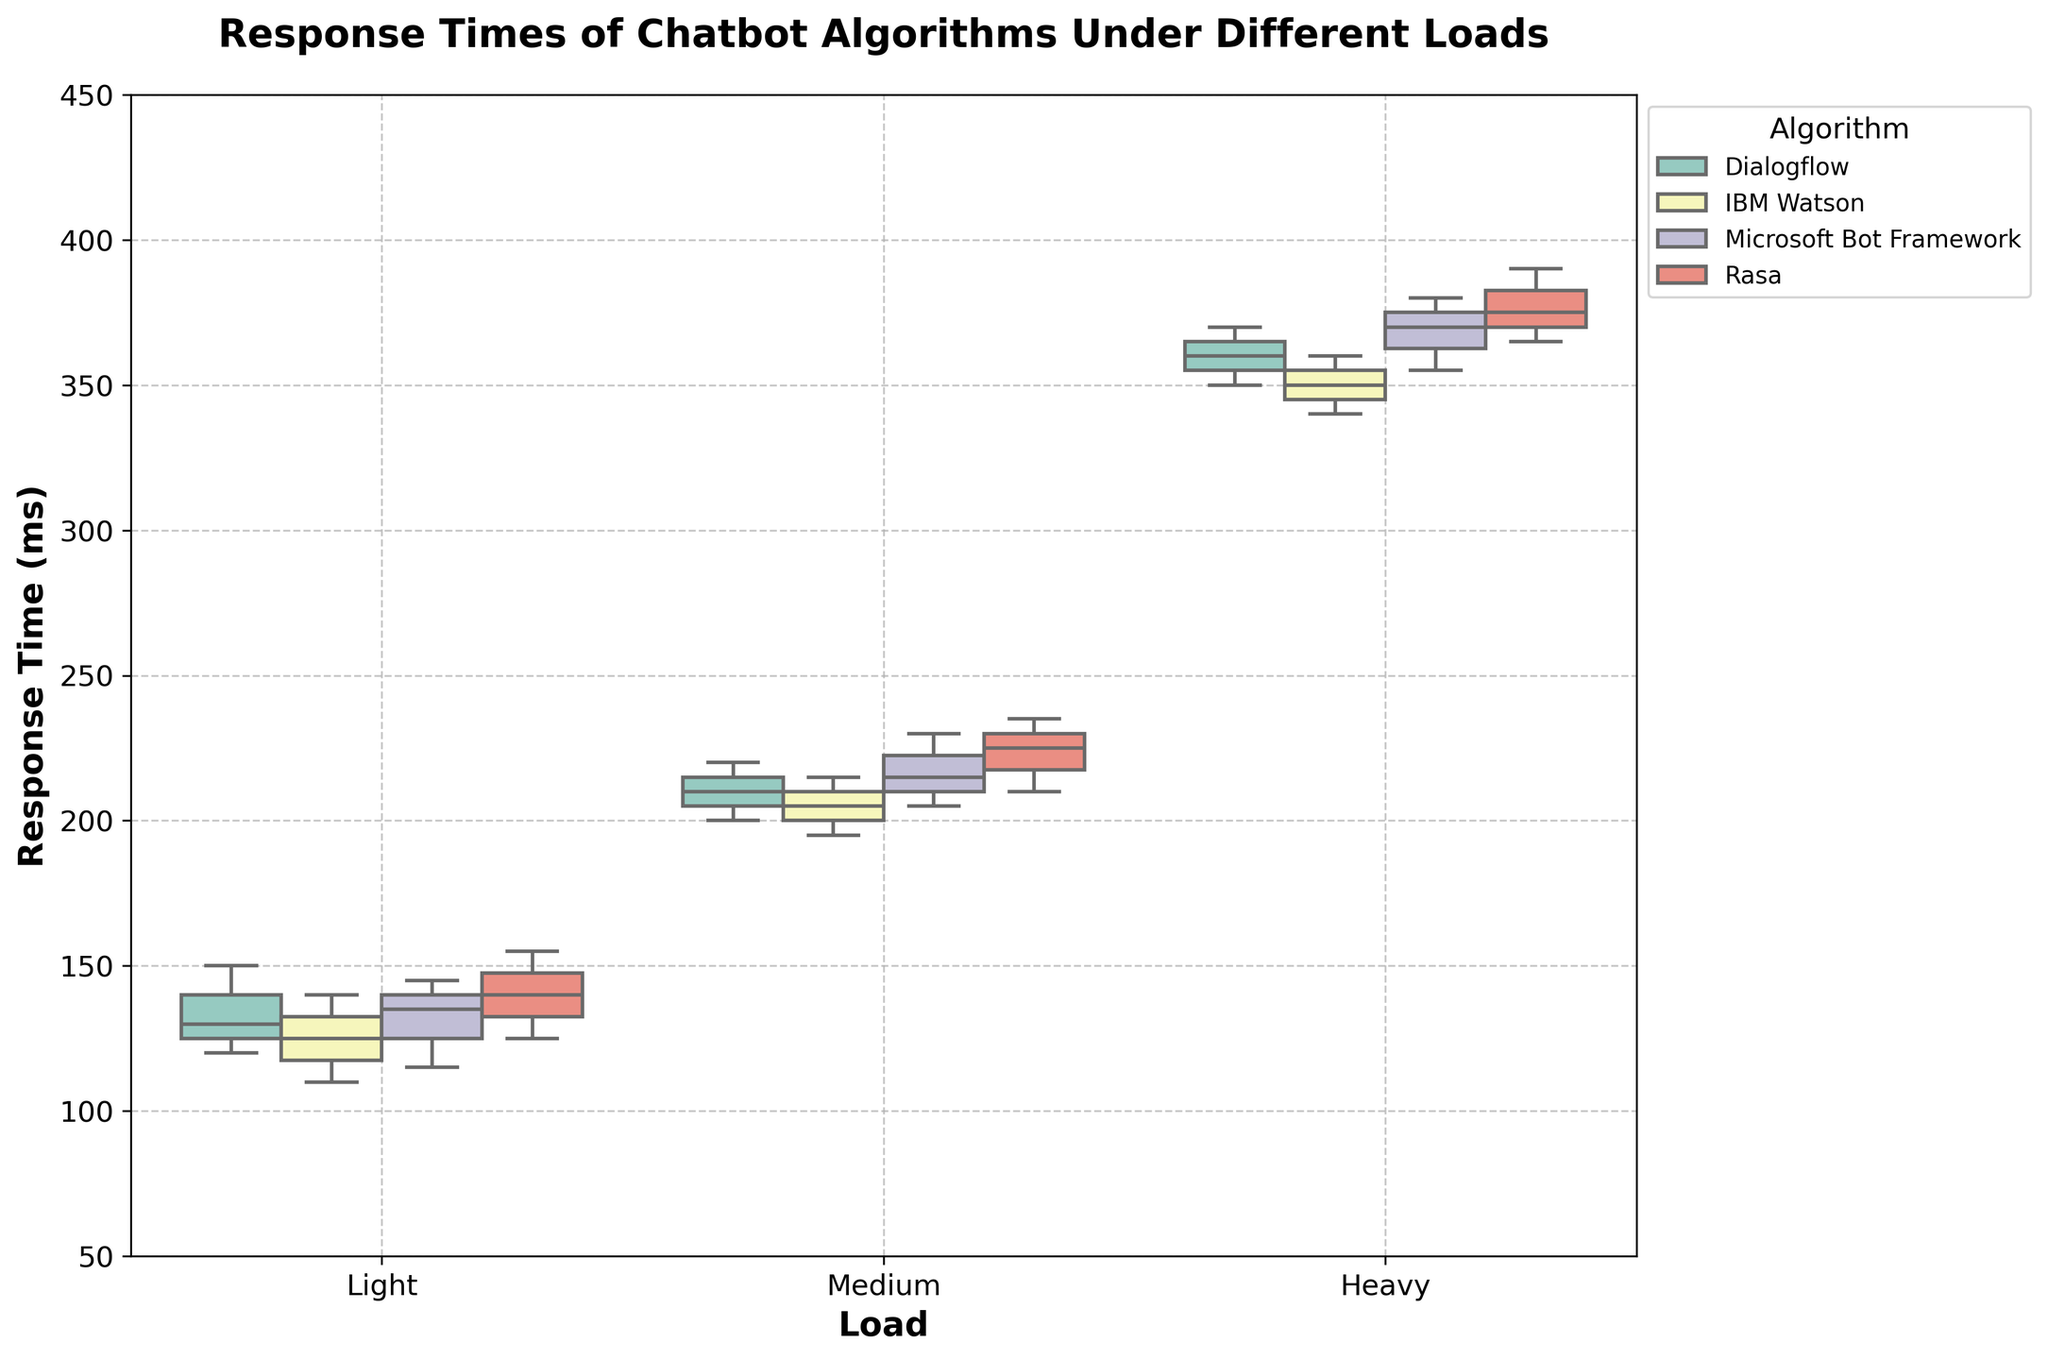What is the title of the figure? The title is located at the top of the figure and provides an overview of what the plot represents. It reads, "Response Times of Chatbot Algorithms Under Different Loads".
Answer: Response Times of Chatbot Algorithms Under Different Loads How are the loads categorized in the figure? The category of loads is displayed on the x-axis of the figure. The loads are categorized into "Light", "Medium", and "Heavy".
Answer: Light, Medium, Heavy Which Chatbot Algorithm has the lowest median response time under light load? The median value can be identified by the line within the box of each box plot. Under light load, "IBM Watson" appears to have the lowest median response time.
Answer: IBM Watson How do the response times vary for Dialogflow under different loads? To understand the variation, we need to look at the position and spread of the boxes and whiskers for "Dialogflow" across "Light", "Medium", and "Heavy" loads. Under light load, the response times range from 120 to 150 ms. Under medium load, they range from 200 to 220 ms. Under heavy load, they range from 350 to 370 ms, showing an overall increase as the load increases.
Answer: They increase as the load increases Which algorithm shows the highest median response time under heavy load? The median value is indicated by the line within each box. For heavy load, "Rasa" shows the highest median response time.
Answer: Rasa How does Microsoft Bot Framework's response time compare across different loads? We can compare the position of the boxes and median lines for "Microsoft Bot Framework" across "Light", "Medium", and "Heavy" loads. Under light load, the response time ranges from 115 to 145 ms. Under medium load, they range from 205 to 230 ms. Under heavy load, they range from 355 to 380 ms, indicating an increase in response time with heavier loads.
Answer: Increases with load What is the overall trend observed in the response times of the algorithms as the load increases from light to heavy? Observing the plot, we can see that for all algorithms, the boxes and median lines shift upwards as the load changes from light to medium to heavy, indicating an overall trend of increasing response times with higher loads.
Answer: Increasing trend Is there any algorithm that has a median response time greater than 200 ms under light load? We need to look at the median lines within the boxes under light load for each algorithm. No algorithms have a median response time greater than 200 ms under light load.
Answer: No What is the range of response times for Rasa under medium load? The range of response times is indicated by the length of the box and the whiskers. For Rasa under medium load, the response times range from 210 to 235 ms.
Answer: 210 to 235 ms 